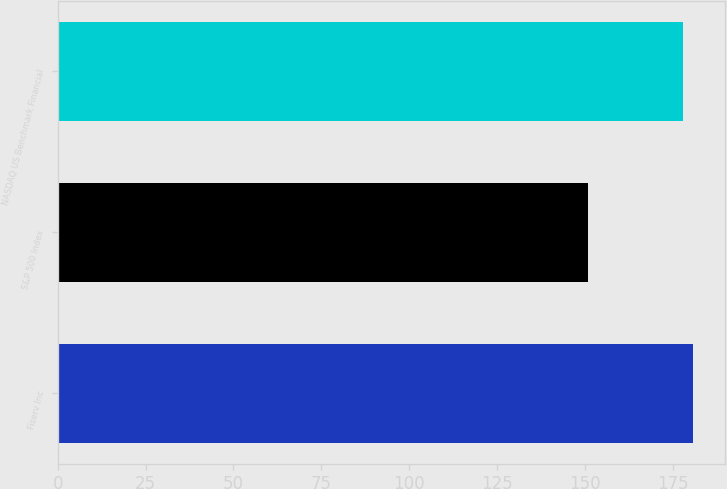Convert chart to OTSL. <chart><loc_0><loc_0><loc_500><loc_500><bar_chart><fcel>Fiserv Inc<fcel>S&P 500 Index<fcel>NASDAQ US Benchmark Financial<nl><fcel>180.9<fcel>151<fcel>178<nl></chart> 